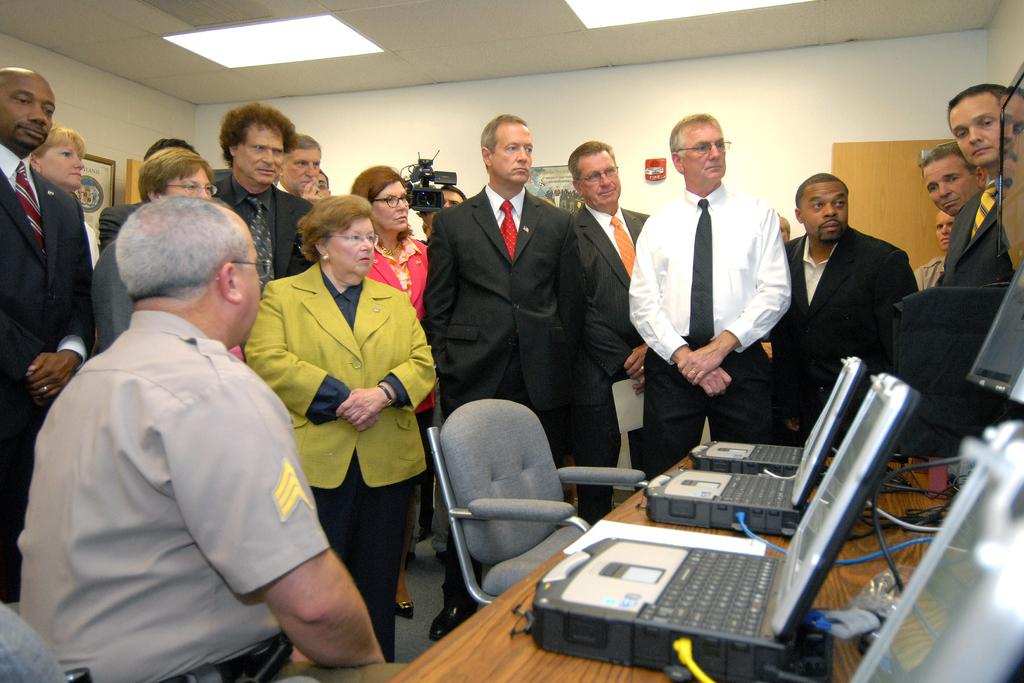What is the person in the image wearing? The person is wearing a brown shirt in the image. What is the person's position in the image? The person is sitting in a chair. What is happening in front of the person? There is a group of people in front of the person. What is located beside the person? There is a table beside the person. What can be found on the table? The table contains electronic devices. Can you see any mountains in the background of the image? There are no mountains visible in the image. How many rings does the person in the image have on their fingers? The image does not show any rings on the person's fingers. Is there any celery present on the table in the image? There is no celery visible on the table in the image. 